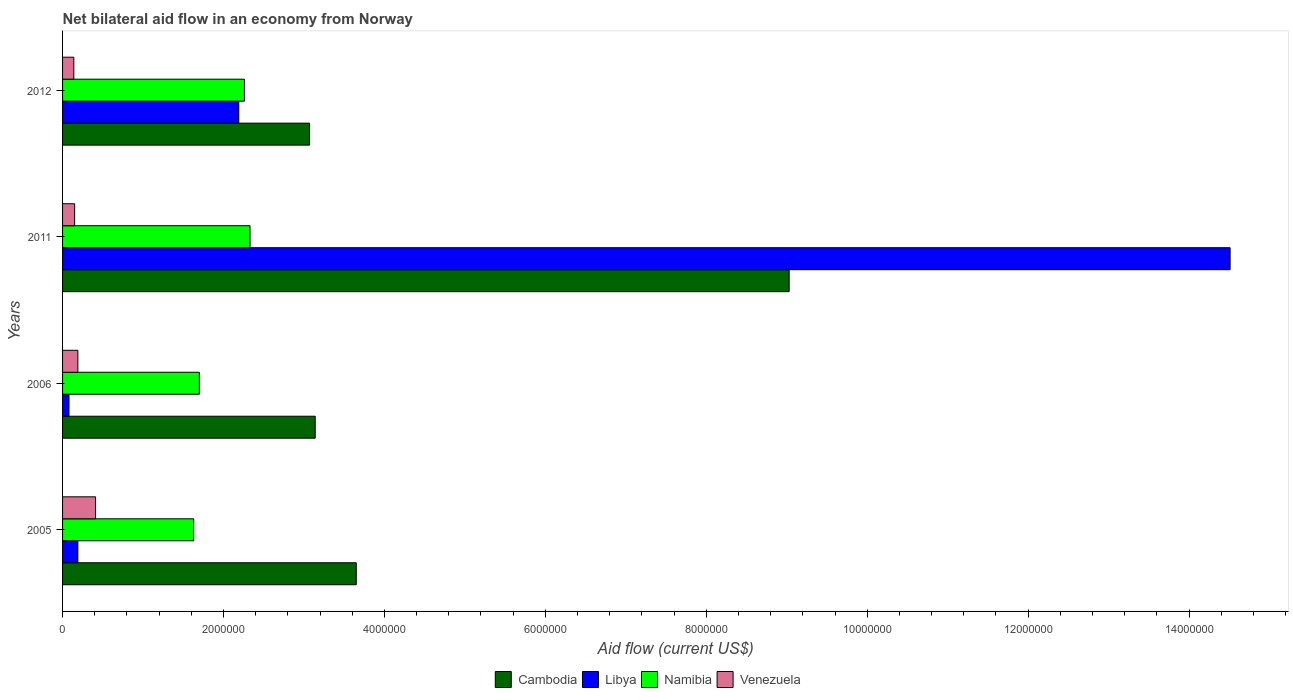How many different coloured bars are there?
Make the answer very short. 4. Are the number of bars per tick equal to the number of legend labels?
Keep it short and to the point. Yes. How many bars are there on the 1st tick from the bottom?
Your answer should be compact. 4. What is the label of the 2nd group of bars from the top?
Your response must be concise. 2011. In how many cases, is the number of bars for a given year not equal to the number of legend labels?
Provide a short and direct response. 0. What is the net bilateral aid flow in Namibia in 2005?
Ensure brevity in your answer.  1.63e+06. Across all years, what is the maximum net bilateral aid flow in Venezuela?
Give a very brief answer. 4.10e+05. Across all years, what is the minimum net bilateral aid flow in Namibia?
Your response must be concise. 1.63e+06. In which year was the net bilateral aid flow in Libya maximum?
Offer a terse response. 2011. What is the total net bilateral aid flow in Venezuela in the graph?
Make the answer very short. 8.90e+05. What is the difference between the net bilateral aid flow in Libya in 2011 and that in 2012?
Keep it short and to the point. 1.23e+07. What is the difference between the net bilateral aid flow in Cambodia in 2011 and the net bilateral aid flow in Venezuela in 2012?
Offer a terse response. 8.89e+06. What is the average net bilateral aid flow in Cambodia per year?
Offer a very short reply. 4.72e+06. In the year 2006, what is the difference between the net bilateral aid flow in Namibia and net bilateral aid flow in Venezuela?
Your answer should be compact. 1.51e+06. In how many years, is the net bilateral aid flow in Libya greater than 4400000 US$?
Offer a very short reply. 1. What is the ratio of the net bilateral aid flow in Libya in 2005 to that in 2006?
Make the answer very short. 2.38. Is the net bilateral aid flow in Venezuela in 2006 less than that in 2012?
Give a very brief answer. No. What is the difference between the highest and the lowest net bilateral aid flow in Venezuela?
Offer a very short reply. 2.70e+05. In how many years, is the net bilateral aid flow in Cambodia greater than the average net bilateral aid flow in Cambodia taken over all years?
Provide a succinct answer. 1. Is the sum of the net bilateral aid flow in Libya in 2005 and 2012 greater than the maximum net bilateral aid flow in Cambodia across all years?
Provide a short and direct response. No. Is it the case that in every year, the sum of the net bilateral aid flow in Namibia and net bilateral aid flow in Libya is greater than the sum of net bilateral aid flow in Cambodia and net bilateral aid flow in Venezuela?
Your answer should be very brief. Yes. What does the 2nd bar from the top in 2005 represents?
Make the answer very short. Namibia. What does the 1st bar from the bottom in 2006 represents?
Keep it short and to the point. Cambodia. How many bars are there?
Keep it short and to the point. 16. Are all the bars in the graph horizontal?
Your answer should be very brief. Yes. How many years are there in the graph?
Provide a succinct answer. 4. What is the difference between two consecutive major ticks on the X-axis?
Make the answer very short. 2.00e+06. Does the graph contain any zero values?
Offer a very short reply. No. Does the graph contain grids?
Provide a succinct answer. No. How are the legend labels stacked?
Offer a terse response. Horizontal. What is the title of the graph?
Offer a very short reply. Net bilateral aid flow in an economy from Norway. What is the Aid flow (current US$) in Cambodia in 2005?
Ensure brevity in your answer.  3.65e+06. What is the Aid flow (current US$) of Namibia in 2005?
Keep it short and to the point. 1.63e+06. What is the Aid flow (current US$) in Cambodia in 2006?
Ensure brevity in your answer.  3.14e+06. What is the Aid flow (current US$) in Namibia in 2006?
Offer a very short reply. 1.70e+06. What is the Aid flow (current US$) of Venezuela in 2006?
Give a very brief answer. 1.90e+05. What is the Aid flow (current US$) in Cambodia in 2011?
Give a very brief answer. 9.03e+06. What is the Aid flow (current US$) in Libya in 2011?
Provide a short and direct response. 1.45e+07. What is the Aid flow (current US$) of Namibia in 2011?
Make the answer very short. 2.33e+06. What is the Aid flow (current US$) in Venezuela in 2011?
Your answer should be very brief. 1.50e+05. What is the Aid flow (current US$) in Cambodia in 2012?
Provide a succinct answer. 3.07e+06. What is the Aid flow (current US$) of Libya in 2012?
Ensure brevity in your answer.  2.19e+06. What is the Aid flow (current US$) of Namibia in 2012?
Your response must be concise. 2.26e+06. Across all years, what is the maximum Aid flow (current US$) in Cambodia?
Offer a terse response. 9.03e+06. Across all years, what is the maximum Aid flow (current US$) of Libya?
Make the answer very short. 1.45e+07. Across all years, what is the maximum Aid flow (current US$) of Namibia?
Your response must be concise. 2.33e+06. Across all years, what is the maximum Aid flow (current US$) of Venezuela?
Your response must be concise. 4.10e+05. Across all years, what is the minimum Aid flow (current US$) of Cambodia?
Your response must be concise. 3.07e+06. Across all years, what is the minimum Aid flow (current US$) in Libya?
Ensure brevity in your answer.  8.00e+04. Across all years, what is the minimum Aid flow (current US$) in Namibia?
Give a very brief answer. 1.63e+06. Across all years, what is the minimum Aid flow (current US$) in Venezuela?
Offer a very short reply. 1.40e+05. What is the total Aid flow (current US$) in Cambodia in the graph?
Ensure brevity in your answer.  1.89e+07. What is the total Aid flow (current US$) in Libya in the graph?
Your answer should be compact. 1.70e+07. What is the total Aid flow (current US$) of Namibia in the graph?
Give a very brief answer. 7.92e+06. What is the total Aid flow (current US$) in Venezuela in the graph?
Make the answer very short. 8.90e+05. What is the difference between the Aid flow (current US$) of Cambodia in 2005 and that in 2006?
Your response must be concise. 5.10e+05. What is the difference between the Aid flow (current US$) in Libya in 2005 and that in 2006?
Give a very brief answer. 1.10e+05. What is the difference between the Aid flow (current US$) of Venezuela in 2005 and that in 2006?
Your answer should be compact. 2.20e+05. What is the difference between the Aid flow (current US$) in Cambodia in 2005 and that in 2011?
Provide a short and direct response. -5.38e+06. What is the difference between the Aid flow (current US$) in Libya in 2005 and that in 2011?
Make the answer very short. -1.43e+07. What is the difference between the Aid flow (current US$) in Namibia in 2005 and that in 2011?
Make the answer very short. -7.00e+05. What is the difference between the Aid flow (current US$) of Venezuela in 2005 and that in 2011?
Keep it short and to the point. 2.60e+05. What is the difference between the Aid flow (current US$) of Cambodia in 2005 and that in 2012?
Offer a terse response. 5.80e+05. What is the difference between the Aid flow (current US$) of Namibia in 2005 and that in 2012?
Keep it short and to the point. -6.30e+05. What is the difference between the Aid flow (current US$) in Cambodia in 2006 and that in 2011?
Provide a short and direct response. -5.89e+06. What is the difference between the Aid flow (current US$) of Libya in 2006 and that in 2011?
Your response must be concise. -1.44e+07. What is the difference between the Aid flow (current US$) of Namibia in 2006 and that in 2011?
Offer a very short reply. -6.30e+05. What is the difference between the Aid flow (current US$) in Venezuela in 2006 and that in 2011?
Provide a succinct answer. 4.00e+04. What is the difference between the Aid flow (current US$) in Libya in 2006 and that in 2012?
Make the answer very short. -2.11e+06. What is the difference between the Aid flow (current US$) in Namibia in 2006 and that in 2012?
Provide a succinct answer. -5.60e+05. What is the difference between the Aid flow (current US$) in Cambodia in 2011 and that in 2012?
Your answer should be compact. 5.96e+06. What is the difference between the Aid flow (current US$) in Libya in 2011 and that in 2012?
Provide a succinct answer. 1.23e+07. What is the difference between the Aid flow (current US$) of Venezuela in 2011 and that in 2012?
Make the answer very short. 10000. What is the difference between the Aid flow (current US$) in Cambodia in 2005 and the Aid flow (current US$) in Libya in 2006?
Keep it short and to the point. 3.57e+06. What is the difference between the Aid flow (current US$) of Cambodia in 2005 and the Aid flow (current US$) of Namibia in 2006?
Make the answer very short. 1.95e+06. What is the difference between the Aid flow (current US$) of Cambodia in 2005 and the Aid flow (current US$) of Venezuela in 2006?
Your response must be concise. 3.46e+06. What is the difference between the Aid flow (current US$) in Libya in 2005 and the Aid flow (current US$) in Namibia in 2006?
Make the answer very short. -1.51e+06. What is the difference between the Aid flow (current US$) in Namibia in 2005 and the Aid flow (current US$) in Venezuela in 2006?
Offer a terse response. 1.44e+06. What is the difference between the Aid flow (current US$) of Cambodia in 2005 and the Aid flow (current US$) of Libya in 2011?
Provide a short and direct response. -1.09e+07. What is the difference between the Aid flow (current US$) of Cambodia in 2005 and the Aid flow (current US$) of Namibia in 2011?
Your answer should be compact. 1.32e+06. What is the difference between the Aid flow (current US$) of Cambodia in 2005 and the Aid flow (current US$) of Venezuela in 2011?
Ensure brevity in your answer.  3.50e+06. What is the difference between the Aid flow (current US$) in Libya in 2005 and the Aid flow (current US$) in Namibia in 2011?
Provide a succinct answer. -2.14e+06. What is the difference between the Aid flow (current US$) in Libya in 2005 and the Aid flow (current US$) in Venezuela in 2011?
Keep it short and to the point. 4.00e+04. What is the difference between the Aid flow (current US$) of Namibia in 2005 and the Aid flow (current US$) of Venezuela in 2011?
Provide a succinct answer. 1.48e+06. What is the difference between the Aid flow (current US$) of Cambodia in 2005 and the Aid flow (current US$) of Libya in 2012?
Your response must be concise. 1.46e+06. What is the difference between the Aid flow (current US$) in Cambodia in 2005 and the Aid flow (current US$) in Namibia in 2012?
Ensure brevity in your answer.  1.39e+06. What is the difference between the Aid flow (current US$) of Cambodia in 2005 and the Aid flow (current US$) of Venezuela in 2012?
Keep it short and to the point. 3.51e+06. What is the difference between the Aid flow (current US$) of Libya in 2005 and the Aid flow (current US$) of Namibia in 2012?
Make the answer very short. -2.07e+06. What is the difference between the Aid flow (current US$) of Libya in 2005 and the Aid flow (current US$) of Venezuela in 2012?
Offer a terse response. 5.00e+04. What is the difference between the Aid flow (current US$) of Namibia in 2005 and the Aid flow (current US$) of Venezuela in 2012?
Keep it short and to the point. 1.49e+06. What is the difference between the Aid flow (current US$) of Cambodia in 2006 and the Aid flow (current US$) of Libya in 2011?
Give a very brief answer. -1.14e+07. What is the difference between the Aid flow (current US$) in Cambodia in 2006 and the Aid flow (current US$) in Namibia in 2011?
Ensure brevity in your answer.  8.10e+05. What is the difference between the Aid flow (current US$) of Cambodia in 2006 and the Aid flow (current US$) of Venezuela in 2011?
Make the answer very short. 2.99e+06. What is the difference between the Aid flow (current US$) in Libya in 2006 and the Aid flow (current US$) in Namibia in 2011?
Provide a succinct answer. -2.25e+06. What is the difference between the Aid flow (current US$) of Libya in 2006 and the Aid flow (current US$) of Venezuela in 2011?
Provide a succinct answer. -7.00e+04. What is the difference between the Aid flow (current US$) of Namibia in 2006 and the Aid flow (current US$) of Venezuela in 2011?
Your answer should be compact. 1.55e+06. What is the difference between the Aid flow (current US$) of Cambodia in 2006 and the Aid flow (current US$) of Libya in 2012?
Offer a very short reply. 9.50e+05. What is the difference between the Aid flow (current US$) in Cambodia in 2006 and the Aid flow (current US$) in Namibia in 2012?
Provide a short and direct response. 8.80e+05. What is the difference between the Aid flow (current US$) of Cambodia in 2006 and the Aid flow (current US$) of Venezuela in 2012?
Provide a succinct answer. 3.00e+06. What is the difference between the Aid flow (current US$) of Libya in 2006 and the Aid flow (current US$) of Namibia in 2012?
Ensure brevity in your answer.  -2.18e+06. What is the difference between the Aid flow (current US$) in Libya in 2006 and the Aid flow (current US$) in Venezuela in 2012?
Keep it short and to the point. -6.00e+04. What is the difference between the Aid flow (current US$) in Namibia in 2006 and the Aid flow (current US$) in Venezuela in 2012?
Your response must be concise. 1.56e+06. What is the difference between the Aid flow (current US$) of Cambodia in 2011 and the Aid flow (current US$) of Libya in 2012?
Offer a very short reply. 6.84e+06. What is the difference between the Aid flow (current US$) of Cambodia in 2011 and the Aid flow (current US$) of Namibia in 2012?
Your answer should be compact. 6.77e+06. What is the difference between the Aid flow (current US$) of Cambodia in 2011 and the Aid flow (current US$) of Venezuela in 2012?
Make the answer very short. 8.89e+06. What is the difference between the Aid flow (current US$) in Libya in 2011 and the Aid flow (current US$) in Namibia in 2012?
Provide a short and direct response. 1.22e+07. What is the difference between the Aid flow (current US$) of Libya in 2011 and the Aid flow (current US$) of Venezuela in 2012?
Keep it short and to the point. 1.44e+07. What is the difference between the Aid flow (current US$) of Namibia in 2011 and the Aid flow (current US$) of Venezuela in 2012?
Offer a very short reply. 2.19e+06. What is the average Aid flow (current US$) in Cambodia per year?
Ensure brevity in your answer.  4.72e+06. What is the average Aid flow (current US$) in Libya per year?
Ensure brevity in your answer.  4.24e+06. What is the average Aid flow (current US$) of Namibia per year?
Give a very brief answer. 1.98e+06. What is the average Aid flow (current US$) of Venezuela per year?
Ensure brevity in your answer.  2.22e+05. In the year 2005, what is the difference between the Aid flow (current US$) in Cambodia and Aid flow (current US$) in Libya?
Your response must be concise. 3.46e+06. In the year 2005, what is the difference between the Aid flow (current US$) in Cambodia and Aid flow (current US$) in Namibia?
Offer a terse response. 2.02e+06. In the year 2005, what is the difference between the Aid flow (current US$) of Cambodia and Aid flow (current US$) of Venezuela?
Your answer should be very brief. 3.24e+06. In the year 2005, what is the difference between the Aid flow (current US$) in Libya and Aid flow (current US$) in Namibia?
Keep it short and to the point. -1.44e+06. In the year 2005, what is the difference between the Aid flow (current US$) of Libya and Aid flow (current US$) of Venezuela?
Offer a terse response. -2.20e+05. In the year 2005, what is the difference between the Aid flow (current US$) of Namibia and Aid flow (current US$) of Venezuela?
Provide a succinct answer. 1.22e+06. In the year 2006, what is the difference between the Aid flow (current US$) in Cambodia and Aid flow (current US$) in Libya?
Offer a terse response. 3.06e+06. In the year 2006, what is the difference between the Aid flow (current US$) of Cambodia and Aid flow (current US$) of Namibia?
Keep it short and to the point. 1.44e+06. In the year 2006, what is the difference between the Aid flow (current US$) in Cambodia and Aid flow (current US$) in Venezuela?
Provide a succinct answer. 2.95e+06. In the year 2006, what is the difference between the Aid flow (current US$) in Libya and Aid flow (current US$) in Namibia?
Provide a short and direct response. -1.62e+06. In the year 2006, what is the difference between the Aid flow (current US$) in Libya and Aid flow (current US$) in Venezuela?
Keep it short and to the point. -1.10e+05. In the year 2006, what is the difference between the Aid flow (current US$) in Namibia and Aid flow (current US$) in Venezuela?
Provide a succinct answer. 1.51e+06. In the year 2011, what is the difference between the Aid flow (current US$) of Cambodia and Aid flow (current US$) of Libya?
Keep it short and to the point. -5.48e+06. In the year 2011, what is the difference between the Aid flow (current US$) of Cambodia and Aid flow (current US$) of Namibia?
Make the answer very short. 6.70e+06. In the year 2011, what is the difference between the Aid flow (current US$) in Cambodia and Aid flow (current US$) in Venezuela?
Provide a succinct answer. 8.88e+06. In the year 2011, what is the difference between the Aid flow (current US$) of Libya and Aid flow (current US$) of Namibia?
Your response must be concise. 1.22e+07. In the year 2011, what is the difference between the Aid flow (current US$) in Libya and Aid flow (current US$) in Venezuela?
Provide a short and direct response. 1.44e+07. In the year 2011, what is the difference between the Aid flow (current US$) of Namibia and Aid flow (current US$) of Venezuela?
Offer a terse response. 2.18e+06. In the year 2012, what is the difference between the Aid flow (current US$) of Cambodia and Aid flow (current US$) of Libya?
Provide a short and direct response. 8.80e+05. In the year 2012, what is the difference between the Aid flow (current US$) in Cambodia and Aid flow (current US$) in Namibia?
Your answer should be compact. 8.10e+05. In the year 2012, what is the difference between the Aid flow (current US$) of Cambodia and Aid flow (current US$) of Venezuela?
Your answer should be compact. 2.93e+06. In the year 2012, what is the difference between the Aid flow (current US$) of Libya and Aid flow (current US$) of Venezuela?
Ensure brevity in your answer.  2.05e+06. In the year 2012, what is the difference between the Aid flow (current US$) in Namibia and Aid flow (current US$) in Venezuela?
Provide a short and direct response. 2.12e+06. What is the ratio of the Aid flow (current US$) in Cambodia in 2005 to that in 2006?
Provide a short and direct response. 1.16. What is the ratio of the Aid flow (current US$) of Libya in 2005 to that in 2006?
Offer a very short reply. 2.38. What is the ratio of the Aid flow (current US$) in Namibia in 2005 to that in 2006?
Your response must be concise. 0.96. What is the ratio of the Aid flow (current US$) of Venezuela in 2005 to that in 2006?
Provide a succinct answer. 2.16. What is the ratio of the Aid flow (current US$) in Cambodia in 2005 to that in 2011?
Your answer should be very brief. 0.4. What is the ratio of the Aid flow (current US$) in Libya in 2005 to that in 2011?
Offer a terse response. 0.01. What is the ratio of the Aid flow (current US$) of Namibia in 2005 to that in 2011?
Give a very brief answer. 0.7. What is the ratio of the Aid flow (current US$) in Venezuela in 2005 to that in 2011?
Provide a short and direct response. 2.73. What is the ratio of the Aid flow (current US$) of Cambodia in 2005 to that in 2012?
Keep it short and to the point. 1.19. What is the ratio of the Aid flow (current US$) of Libya in 2005 to that in 2012?
Provide a short and direct response. 0.09. What is the ratio of the Aid flow (current US$) in Namibia in 2005 to that in 2012?
Offer a very short reply. 0.72. What is the ratio of the Aid flow (current US$) in Venezuela in 2005 to that in 2012?
Offer a terse response. 2.93. What is the ratio of the Aid flow (current US$) in Cambodia in 2006 to that in 2011?
Offer a very short reply. 0.35. What is the ratio of the Aid flow (current US$) in Libya in 2006 to that in 2011?
Ensure brevity in your answer.  0.01. What is the ratio of the Aid flow (current US$) of Namibia in 2006 to that in 2011?
Offer a terse response. 0.73. What is the ratio of the Aid flow (current US$) of Venezuela in 2006 to that in 2011?
Offer a terse response. 1.27. What is the ratio of the Aid flow (current US$) in Cambodia in 2006 to that in 2012?
Provide a short and direct response. 1.02. What is the ratio of the Aid flow (current US$) in Libya in 2006 to that in 2012?
Your response must be concise. 0.04. What is the ratio of the Aid flow (current US$) in Namibia in 2006 to that in 2012?
Offer a terse response. 0.75. What is the ratio of the Aid flow (current US$) in Venezuela in 2006 to that in 2012?
Ensure brevity in your answer.  1.36. What is the ratio of the Aid flow (current US$) in Cambodia in 2011 to that in 2012?
Your response must be concise. 2.94. What is the ratio of the Aid flow (current US$) in Libya in 2011 to that in 2012?
Offer a terse response. 6.63. What is the ratio of the Aid flow (current US$) of Namibia in 2011 to that in 2012?
Provide a succinct answer. 1.03. What is the ratio of the Aid flow (current US$) of Venezuela in 2011 to that in 2012?
Keep it short and to the point. 1.07. What is the difference between the highest and the second highest Aid flow (current US$) of Cambodia?
Your answer should be very brief. 5.38e+06. What is the difference between the highest and the second highest Aid flow (current US$) of Libya?
Ensure brevity in your answer.  1.23e+07. What is the difference between the highest and the lowest Aid flow (current US$) of Cambodia?
Your answer should be compact. 5.96e+06. What is the difference between the highest and the lowest Aid flow (current US$) in Libya?
Offer a terse response. 1.44e+07. 